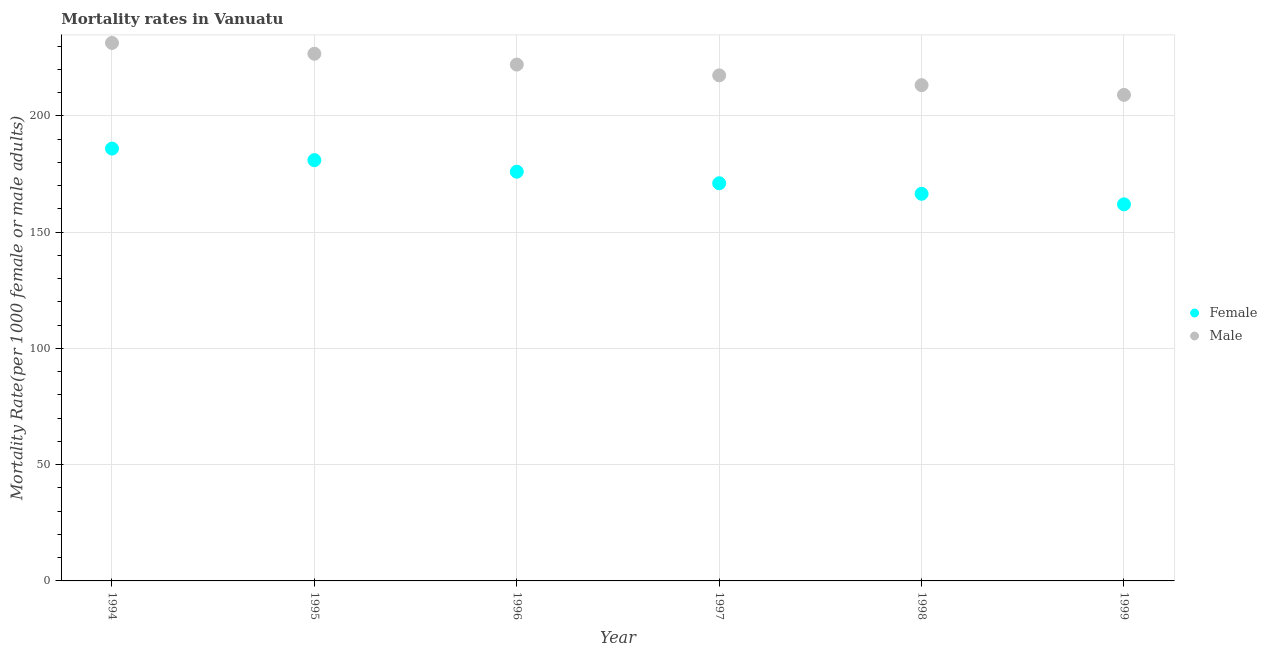What is the female mortality rate in 1997?
Make the answer very short. 171.06. Across all years, what is the maximum female mortality rate?
Offer a very short reply. 185.98. Across all years, what is the minimum male mortality rate?
Offer a very short reply. 209.08. In which year was the female mortality rate minimum?
Your response must be concise. 1999. What is the total female mortality rate in the graph?
Keep it short and to the point. 1042.62. What is the difference between the female mortality rate in 1994 and that in 1997?
Make the answer very short. 14.92. What is the difference between the male mortality rate in 1997 and the female mortality rate in 1994?
Provide a succinct answer. 31.49. What is the average female mortality rate per year?
Provide a succinct answer. 173.77. In the year 1995, what is the difference between the female mortality rate and male mortality rate?
Offer a very short reply. -45.77. What is the ratio of the female mortality rate in 1994 to that in 1995?
Ensure brevity in your answer.  1.03. What is the difference between the highest and the second highest male mortality rate?
Provide a short and direct response. 4.65. What is the difference between the highest and the lowest female mortality rate?
Keep it short and to the point. 23.98. How many dotlines are there?
Keep it short and to the point. 2. How many years are there in the graph?
Provide a succinct answer. 6. What is the difference between two consecutive major ticks on the Y-axis?
Your answer should be very brief. 50. Does the graph contain grids?
Offer a very short reply. Yes. Where does the legend appear in the graph?
Make the answer very short. Center right. How many legend labels are there?
Make the answer very short. 2. What is the title of the graph?
Keep it short and to the point. Mortality rates in Vanuatu. What is the label or title of the X-axis?
Provide a short and direct response. Year. What is the label or title of the Y-axis?
Ensure brevity in your answer.  Mortality Rate(per 1000 female or male adults). What is the Mortality Rate(per 1000 female or male adults) in Female in 1994?
Your response must be concise. 185.98. What is the Mortality Rate(per 1000 female or male adults) of Male in 1994?
Your answer should be compact. 231.43. What is the Mortality Rate(per 1000 female or male adults) in Female in 1995?
Your answer should be compact. 181.01. What is the Mortality Rate(per 1000 female or male adults) of Male in 1995?
Offer a very short reply. 226.77. What is the Mortality Rate(per 1000 female or male adults) in Female in 1996?
Ensure brevity in your answer.  176.04. What is the Mortality Rate(per 1000 female or male adults) of Male in 1996?
Make the answer very short. 222.12. What is the Mortality Rate(per 1000 female or male adults) of Female in 1997?
Your answer should be compact. 171.06. What is the Mortality Rate(per 1000 female or male adults) in Male in 1997?
Ensure brevity in your answer.  217.47. What is the Mortality Rate(per 1000 female or male adults) in Female in 1998?
Offer a very short reply. 166.53. What is the Mortality Rate(per 1000 female or male adults) of Male in 1998?
Your answer should be very brief. 213.28. What is the Mortality Rate(per 1000 female or male adults) in Female in 1999?
Provide a short and direct response. 162. What is the Mortality Rate(per 1000 female or male adults) of Male in 1999?
Give a very brief answer. 209.08. Across all years, what is the maximum Mortality Rate(per 1000 female or male adults) in Female?
Your response must be concise. 185.98. Across all years, what is the maximum Mortality Rate(per 1000 female or male adults) of Male?
Provide a short and direct response. 231.43. Across all years, what is the minimum Mortality Rate(per 1000 female or male adults) in Female?
Give a very brief answer. 162. Across all years, what is the minimum Mortality Rate(per 1000 female or male adults) in Male?
Your answer should be compact. 209.08. What is the total Mortality Rate(per 1000 female or male adults) in Female in the graph?
Make the answer very short. 1042.62. What is the total Mortality Rate(per 1000 female or male adults) of Male in the graph?
Make the answer very short. 1320.15. What is the difference between the Mortality Rate(per 1000 female or male adults) of Female in 1994 and that in 1995?
Offer a very short reply. 4.97. What is the difference between the Mortality Rate(per 1000 female or male adults) of Male in 1994 and that in 1995?
Your answer should be very brief. 4.65. What is the difference between the Mortality Rate(per 1000 female or male adults) in Female in 1994 and that in 1996?
Ensure brevity in your answer.  9.95. What is the difference between the Mortality Rate(per 1000 female or male adults) of Male in 1994 and that in 1996?
Give a very brief answer. 9.3. What is the difference between the Mortality Rate(per 1000 female or male adults) in Female in 1994 and that in 1997?
Your response must be concise. 14.92. What is the difference between the Mortality Rate(per 1000 female or male adults) in Male in 1994 and that in 1997?
Offer a very short reply. 13.96. What is the difference between the Mortality Rate(per 1000 female or male adults) in Female in 1994 and that in 1998?
Your answer should be compact. 19.45. What is the difference between the Mortality Rate(per 1000 female or male adults) of Male in 1994 and that in 1998?
Your answer should be compact. 18.15. What is the difference between the Mortality Rate(per 1000 female or male adults) in Female in 1994 and that in 1999?
Your answer should be compact. 23.98. What is the difference between the Mortality Rate(per 1000 female or male adults) of Male in 1994 and that in 1999?
Ensure brevity in your answer.  22.34. What is the difference between the Mortality Rate(per 1000 female or male adults) of Female in 1995 and that in 1996?
Offer a very short reply. 4.97. What is the difference between the Mortality Rate(per 1000 female or male adults) of Male in 1995 and that in 1996?
Give a very brief answer. 4.65. What is the difference between the Mortality Rate(per 1000 female or male adults) of Female in 1995 and that in 1997?
Provide a short and direct response. 9.95. What is the difference between the Mortality Rate(per 1000 female or male adults) of Male in 1995 and that in 1997?
Your answer should be compact. 9.3. What is the difference between the Mortality Rate(per 1000 female or male adults) in Female in 1995 and that in 1998?
Offer a very short reply. 14.48. What is the difference between the Mortality Rate(per 1000 female or male adults) of Male in 1995 and that in 1998?
Make the answer very short. 13.5. What is the difference between the Mortality Rate(per 1000 female or male adults) in Female in 1995 and that in 1999?
Your response must be concise. 19.01. What is the difference between the Mortality Rate(per 1000 female or male adults) in Male in 1995 and that in 1999?
Your answer should be very brief. 17.69. What is the difference between the Mortality Rate(per 1000 female or male adults) in Female in 1996 and that in 1997?
Give a very brief answer. 4.97. What is the difference between the Mortality Rate(per 1000 female or male adults) of Male in 1996 and that in 1997?
Provide a succinct answer. 4.65. What is the difference between the Mortality Rate(per 1000 female or male adults) of Female in 1996 and that in 1998?
Offer a very short reply. 9.51. What is the difference between the Mortality Rate(per 1000 female or male adults) of Male in 1996 and that in 1998?
Offer a very short reply. 8.85. What is the difference between the Mortality Rate(per 1000 female or male adults) in Female in 1996 and that in 1999?
Your response must be concise. 14.04. What is the difference between the Mortality Rate(per 1000 female or male adults) in Male in 1996 and that in 1999?
Make the answer very short. 13.04. What is the difference between the Mortality Rate(per 1000 female or male adults) in Female in 1997 and that in 1998?
Your answer should be compact. 4.53. What is the difference between the Mortality Rate(per 1000 female or male adults) of Male in 1997 and that in 1998?
Give a very brief answer. 4.19. What is the difference between the Mortality Rate(per 1000 female or male adults) in Female in 1997 and that in 1999?
Provide a short and direct response. 9.06. What is the difference between the Mortality Rate(per 1000 female or male adults) of Male in 1997 and that in 1999?
Your answer should be compact. 8.39. What is the difference between the Mortality Rate(per 1000 female or male adults) in Female in 1998 and that in 1999?
Keep it short and to the point. 4.53. What is the difference between the Mortality Rate(per 1000 female or male adults) of Male in 1998 and that in 1999?
Offer a terse response. 4.19. What is the difference between the Mortality Rate(per 1000 female or male adults) of Female in 1994 and the Mortality Rate(per 1000 female or male adults) of Male in 1995?
Provide a succinct answer. -40.79. What is the difference between the Mortality Rate(per 1000 female or male adults) in Female in 1994 and the Mortality Rate(per 1000 female or male adults) in Male in 1996?
Keep it short and to the point. -36.14. What is the difference between the Mortality Rate(per 1000 female or male adults) in Female in 1994 and the Mortality Rate(per 1000 female or male adults) in Male in 1997?
Offer a terse response. -31.49. What is the difference between the Mortality Rate(per 1000 female or male adults) of Female in 1994 and the Mortality Rate(per 1000 female or male adults) of Male in 1998?
Your answer should be very brief. -27.3. What is the difference between the Mortality Rate(per 1000 female or male adults) of Female in 1994 and the Mortality Rate(per 1000 female or male adults) of Male in 1999?
Your answer should be compact. -23.1. What is the difference between the Mortality Rate(per 1000 female or male adults) of Female in 1995 and the Mortality Rate(per 1000 female or male adults) of Male in 1996?
Keep it short and to the point. -41.11. What is the difference between the Mortality Rate(per 1000 female or male adults) in Female in 1995 and the Mortality Rate(per 1000 female or male adults) in Male in 1997?
Keep it short and to the point. -36.46. What is the difference between the Mortality Rate(per 1000 female or male adults) of Female in 1995 and the Mortality Rate(per 1000 female or male adults) of Male in 1998?
Offer a terse response. -32.27. What is the difference between the Mortality Rate(per 1000 female or male adults) in Female in 1995 and the Mortality Rate(per 1000 female or male adults) in Male in 1999?
Provide a succinct answer. -28.07. What is the difference between the Mortality Rate(per 1000 female or male adults) of Female in 1996 and the Mortality Rate(per 1000 female or male adults) of Male in 1997?
Provide a short and direct response. -41.43. What is the difference between the Mortality Rate(per 1000 female or male adults) of Female in 1996 and the Mortality Rate(per 1000 female or male adults) of Male in 1998?
Your response must be concise. -37.24. What is the difference between the Mortality Rate(per 1000 female or male adults) of Female in 1996 and the Mortality Rate(per 1000 female or male adults) of Male in 1999?
Your answer should be very brief. -33.05. What is the difference between the Mortality Rate(per 1000 female or male adults) in Female in 1997 and the Mortality Rate(per 1000 female or male adults) in Male in 1998?
Ensure brevity in your answer.  -42.21. What is the difference between the Mortality Rate(per 1000 female or male adults) in Female in 1997 and the Mortality Rate(per 1000 female or male adults) in Male in 1999?
Your answer should be very brief. -38.02. What is the difference between the Mortality Rate(per 1000 female or male adults) in Female in 1998 and the Mortality Rate(per 1000 female or male adults) in Male in 1999?
Keep it short and to the point. -42.55. What is the average Mortality Rate(per 1000 female or male adults) in Female per year?
Your answer should be compact. 173.77. What is the average Mortality Rate(per 1000 female or male adults) of Male per year?
Your answer should be very brief. 220.02. In the year 1994, what is the difference between the Mortality Rate(per 1000 female or male adults) in Female and Mortality Rate(per 1000 female or male adults) in Male?
Keep it short and to the point. -45.44. In the year 1995, what is the difference between the Mortality Rate(per 1000 female or male adults) in Female and Mortality Rate(per 1000 female or male adults) in Male?
Provide a succinct answer. -45.77. In the year 1996, what is the difference between the Mortality Rate(per 1000 female or male adults) in Female and Mortality Rate(per 1000 female or male adults) in Male?
Your answer should be very brief. -46.09. In the year 1997, what is the difference between the Mortality Rate(per 1000 female or male adults) of Female and Mortality Rate(per 1000 female or male adults) of Male?
Your answer should be very brief. -46.41. In the year 1998, what is the difference between the Mortality Rate(per 1000 female or male adults) of Female and Mortality Rate(per 1000 female or male adults) of Male?
Keep it short and to the point. -46.75. In the year 1999, what is the difference between the Mortality Rate(per 1000 female or male adults) in Female and Mortality Rate(per 1000 female or male adults) in Male?
Ensure brevity in your answer.  -47.08. What is the ratio of the Mortality Rate(per 1000 female or male adults) in Female in 1994 to that in 1995?
Your answer should be compact. 1.03. What is the ratio of the Mortality Rate(per 1000 female or male adults) of Male in 1994 to that in 1995?
Make the answer very short. 1.02. What is the ratio of the Mortality Rate(per 1000 female or male adults) of Female in 1994 to that in 1996?
Ensure brevity in your answer.  1.06. What is the ratio of the Mortality Rate(per 1000 female or male adults) of Male in 1994 to that in 1996?
Your response must be concise. 1.04. What is the ratio of the Mortality Rate(per 1000 female or male adults) of Female in 1994 to that in 1997?
Offer a very short reply. 1.09. What is the ratio of the Mortality Rate(per 1000 female or male adults) in Male in 1994 to that in 1997?
Provide a short and direct response. 1.06. What is the ratio of the Mortality Rate(per 1000 female or male adults) in Female in 1994 to that in 1998?
Your answer should be very brief. 1.12. What is the ratio of the Mortality Rate(per 1000 female or male adults) of Male in 1994 to that in 1998?
Your answer should be compact. 1.09. What is the ratio of the Mortality Rate(per 1000 female or male adults) in Female in 1994 to that in 1999?
Offer a terse response. 1.15. What is the ratio of the Mortality Rate(per 1000 female or male adults) of Male in 1994 to that in 1999?
Keep it short and to the point. 1.11. What is the ratio of the Mortality Rate(per 1000 female or male adults) of Female in 1995 to that in 1996?
Provide a succinct answer. 1.03. What is the ratio of the Mortality Rate(per 1000 female or male adults) in Male in 1995 to that in 1996?
Offer a very short reply. 1.02. What is the ratio of the Mortality Rate(per 1000 female or male adults) of Female in 1995 to that in 1997?
Provide a succinct answer. 1.06. What is the ratio of the Mortality Rate(per 1000 female or male adults) of Male in 1995 to that in 1997?
Offer a terse response. 1.04. What is the ratio of the Mortality Rate(per 1000 female or male adults) in Female in 1995 to that in 1998?
Your response must be concise. 1.09. What is the ratio of the Mortality Rate(per 1000 female or male adults) of Male in 1995 to that in 1998?
Give a very brief answer. 1.06. What is the ratio of the Mortality Rate(per 1000 female or male adults) in Female in 1995 to that in 1999?
Give a very brief answer. 1.12. What is the ratio of the Mortality Rate(per 1000 female or male adults) in Male in 1995 to that in 1999?
Ensure brevity in your answer.  1.08. What is the ratio of the Mortality Rate(per 1000 female or male adults) of Female in 1996 to that in 1997?
Provide a succinct answer. 1.03. What is the ratio of the Mortality Rate(per 1000 female or male adults) of Male in 1996 to that in 1997?
Make the answer very short. 1.02. What is the ratio of the Mortality Rate(per 1000 female or male adults) of Female in 1996 to that in 1998?
Make the answer very short. 1.06. What is the ratio of the Mortality Rate(per 1000 female or male adults) of Male in 1996 to that in 1998?
Provide a short and direct response. 1.04. What is the ratio of the Mortality Rate(per 1000 female or male adults) in Female in 1996 to that in 1999?
Offer a terse response. 1.09. What is the ratio of the Mortality Rate(per 1000 female or male adults) of Male in 1996 to that in 1999?
Offer a terse response. 1.06. What is the ratio of the Mortality Rate(per 1000 female or male adults) in Female in 1997 to that in 1998?
Your answer should be compact. 1.03. What is the ratio of the Mortality Rate(per 1000 female or male adults) of Male in 1997 to that in 1998?
Keep it short and to the point. 1.02. What is the ratio of the Mortality Rate(per 1000 female or male adults) in Female in 1997 to that in 1999?
Provide a short and direct response. 1.06. What is the ratio of the Mortality Rate(per 1000 female or male adults) of Male in 1997 to that in 1999?
Give a very brief answer. 1.04. What is the ratio of the Mortality Rate(per 1000 female or male adults) in Female in 1998 to that in 1999?
Your response must be concise. 1.03. What is the ratio of the Mortality Rate(per 1000 female or male adults) of Male in 1998 to that in 1999?
Offer a very short reply. 1.02. What is the difference between the highest and the second highest Mortality Rate(per 1000 female or male adults) of Female?
Offer a terse response. 4.97. What is the difference between the highest and the second highest Mortality Rate(per 1000 female or male adults) of Male?
Provide a short and direct response. 4.65. What is the difference between the highest and the lowest Mortality Rate(per 1000 female or male adults) of Female?
Provide a short and direct response. 23.98. What is the difference between the highest and the lowest Mortality Rate(per 1000 female or male adults) in Male?
Your answer should be compact. 22.34. 